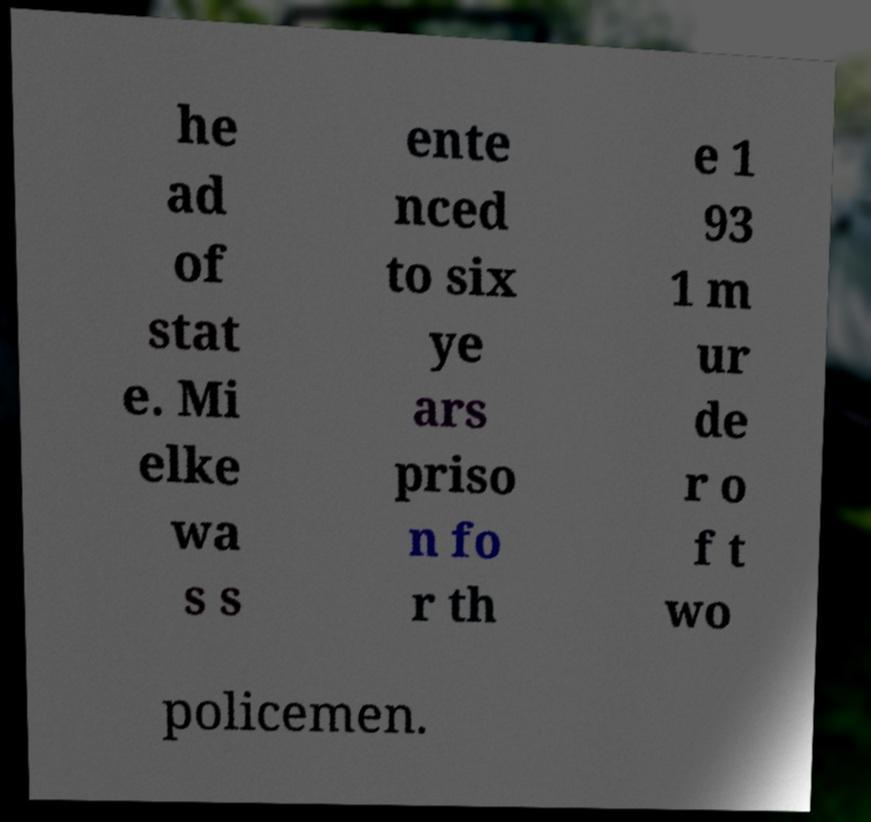Can you accurately transcribe the text from the provided image for me? he ad of stat e. Mi elke wa s s ente nced to six ye ars priso n fo r th e 1 93 1 m ur de r o f t wo policemen. 